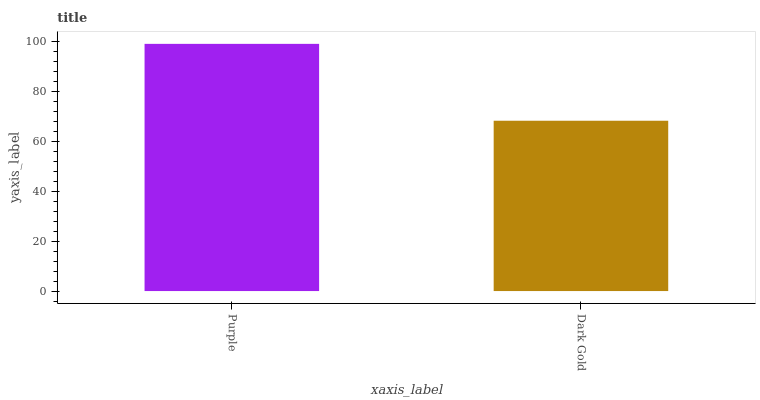Is Dark Gold the minimum?
Answer yes or no. Yes. Is Purple the maximum?
Answer yes or no. Yes. Is Dark Gold the maximum?
Answer yes or no. No. Is Purple greater than Dark Gold?
Answer yes or no. Yes. Is Dark Gold less than Purple?
Answer yes or no. Yes. Is Dark Gold greater than Purple?
Answer yes or no. No. Is Purple less than Dark Gold?
Answer yes or no. No. Is Purple the high median?
Answer yes or no. Yes. Is Dark Gold the low median?
Answer yes or no. Yes. Is Dark Gold the high median?
Answer yes or no. No. Is Purple the low median?
Answer yes or no. No. 